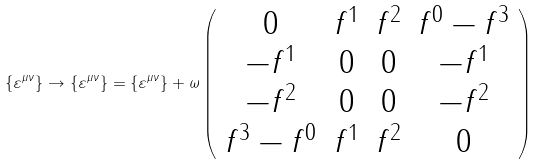Convert formula to latex. <formula><loc_0><loc_0><loc_500><loc_500>\{ \varepsilon ^ { \mu \nu } \} \rightarrow \{ \varepsilon ^ { \mu \nu } \} = \{ \varepsilon ^ { \mu \nu } \} + \omega \left ( \begin{array} { c c c c } { 0 } & { { f ^ { 1 } } } & { { f ^ { 2 } } } & { { f ^ { 0 } - f ^ { 3 } } } \\ { { - f ^ { 1 } } } & { 0 } & { 0 } & { { - f ^ { 1 } } } \\ { { - f ^ { 2 } } } & { 0 } & { 0 } & { { - f ^ { 2 } } } \\ { { f ^ { 3 } - f ^ { 0 } } } & { { f ^ { 1 } } } & { { f ^ { 2 } } } & { 0 } \end{array} \right )</formula> 